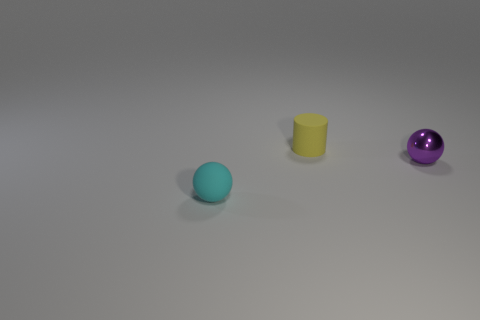What size is the cyan ball?
Your answer should be compact. Small. How many metallic spheres have the same size as the purple thing?
Your answer should be very brief. 0. What number of large blue matte things have the same shape as the small cyan object?
Ensure brevity in your answer.  0. Are there the same number of small purple objects that are behind the small yellow matte cylinder and big cyan cylinders?
Your answer should be very brief. Yes. Are there any other things that have the same size as the cyan sphere?
Offer a terse response. Yes. There is a yellow object that is the same size as the purple sphere; what is its shape?
Your response must be concise. Cylinder. Is there a yellow matte object that has the same shape as the cyan rubber object?
Make the answer very short. No. Is there a tiny yellow rubber thing in front of the small matte thing that is to the right of the tiny thing to the left of the tiny yellow matte object?
Ensure brevity in your answer.  No. Is the number of purple shiny balls that are to the left of the shiny sphere greater than the number of tiny yellow rubber things that are to the right of the small cylinder?
Your response must be concise. No. There is another ball that is the same size as the purple metal sphere; what is it made of?
Offer a very short reply. Rubber. 